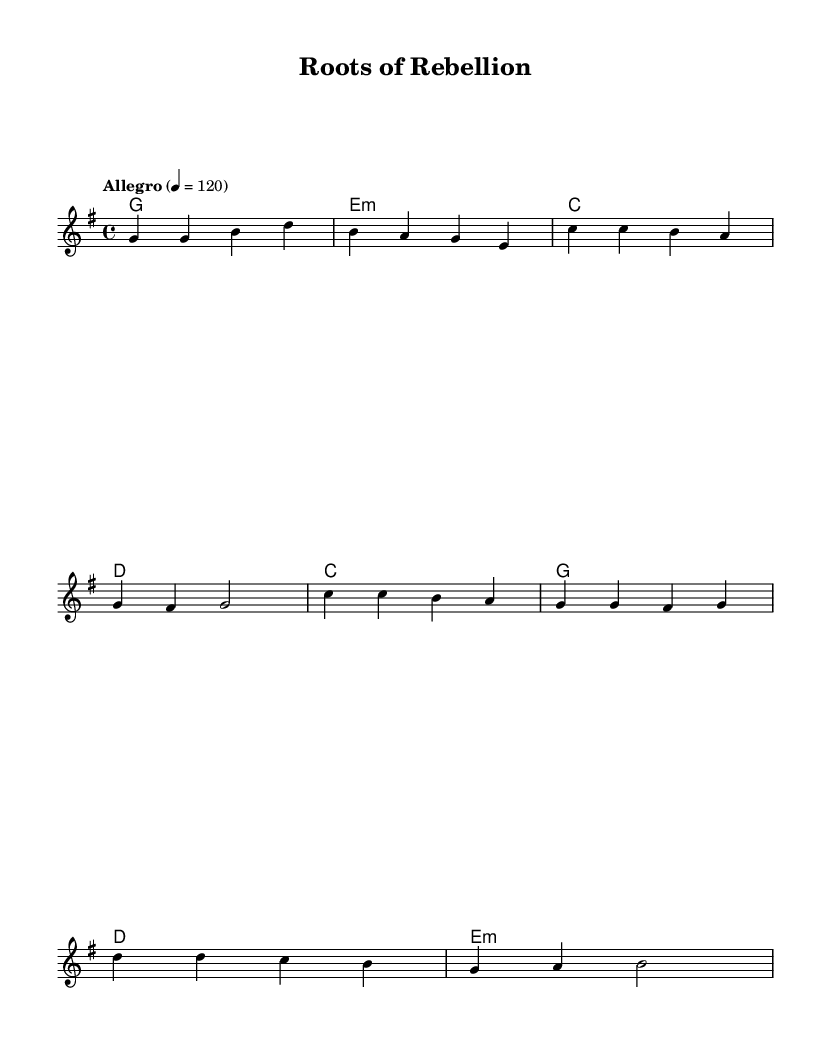What is the key signature of this music? The key signature is G major, which has one sharp (F#).
Answer: G major What is the time signature of this piece? The time signature is 4/4, indicating four beats per measure.
Answer: 4/4 What is the tempo marking for this music? The tempo marking is "Allegro," which means the piece should be played fast, at a speed of 120 beats per minute.
Answer: Allegro How many measures are there in the chorus section? The chorus section consists of four measures, as indicated by the grouping of notes written under the word "Chorus."
Answer: Four What is the primary theme conveyed in the lyrics? The lyrics generally focus on environmental themes and community empowerment. This is indicated by the phrases "environmental themes" and "community empowerment and change."
Answer: Environmental themes and community empowerment What is the style of the harmonies used in this piece? The harmonies consist primarily of simple major and minor chords, which is a hallmark of folk and punk-influenced music, emphasizing straightforward chord progressions.
Answer: Major and minor chords What does the use of acoustic instruments imply about the genre of this music? The use of acoustic instruments suggests a connection to folk music roots, which is typical for punk-influenced folk music, aiming to emphasize authenticity and social messages.
Answer: Acoustic instruments 